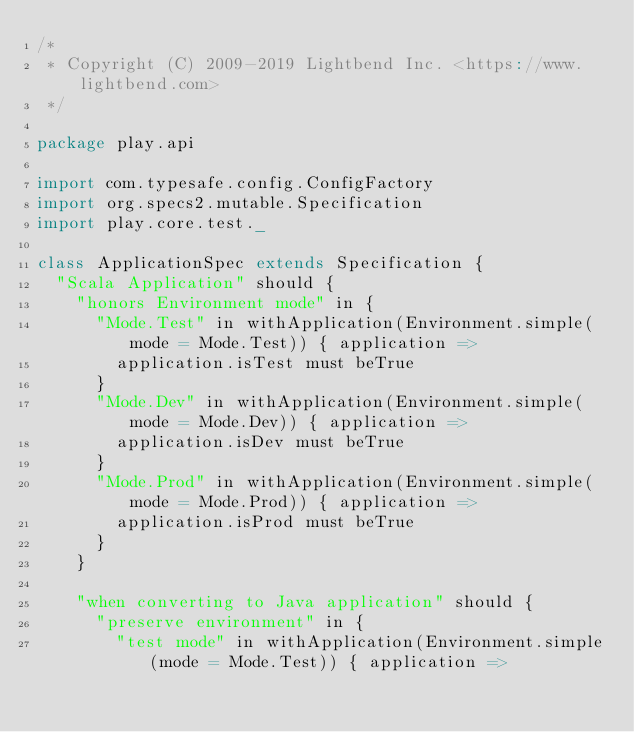<code> <loc_0><loc_0><loc_500><loc_500><_Scala_>/*
 * Copyright (C) 2009-2019 Lightbend Inc. <https://www.lightbend.com>
 */

package play.api

import com.typesafe.config.ConfigFactory
import org.specs2.mutable.Specification
import play.core.test._

class ApplicationSpec extends Specification {
  "Scala Application" should {
    "honors Environment mode" in {
      "Mode.Test" in withApplication(Environment.simple(mode = Mode.Test)) { application =>
        application.isTest must beTrue
      }
      "Mode.Dev" in withApplication(Environment.simple(mode = Mode.Dev)) { application =>
        application.isDev must beTrue
      }
      "Mode.Prod" in withApplication(Environment.simple(mode = Mode.Prod)) { application =>
        application.isProd must beTrue
      }
    }

    "when converting to Java application" should {
      "preserve environment" in {
        "test mode" in withApplication(Environment.simple(mode = Mode.Test)) { application =></code> 